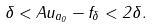<formula> <loc_0><loc_0><loc_500><loc_500>\delta < \| A u _ { a _ { 0 } } - f _ { \delta } \| < 2 \delta .</formula> 